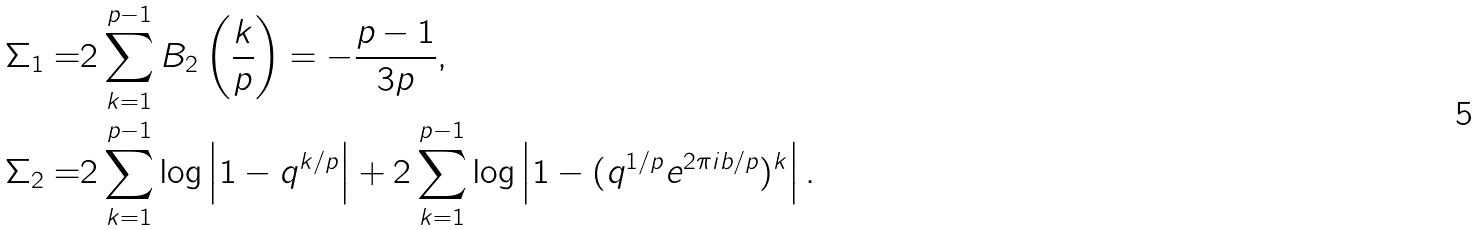Convert formula to latex. <formula><loc_0><loc_0><loc_500><loc_500>\Sigma _ { 1 } = & 2 \sum _ { k = 1 } ^ { p - 1 } B _ { 2 } \left ( \frac { k } { p } \right ) = - \frac { p - 1 } { 3 p } , \\ \Sigma _ { 2 } = & 2 \sum _ { k = 1 } ^ { p - 1 } \log \left | 1 - q ^ { k / p } \right | + 2 \sum _ { k = 1 } ^ { p - 1 } \log \left | 1 - ( q ^ { 1 / p } e ^ { 2 \pi i b / p } ) ^ { k } \right | .</formula> 